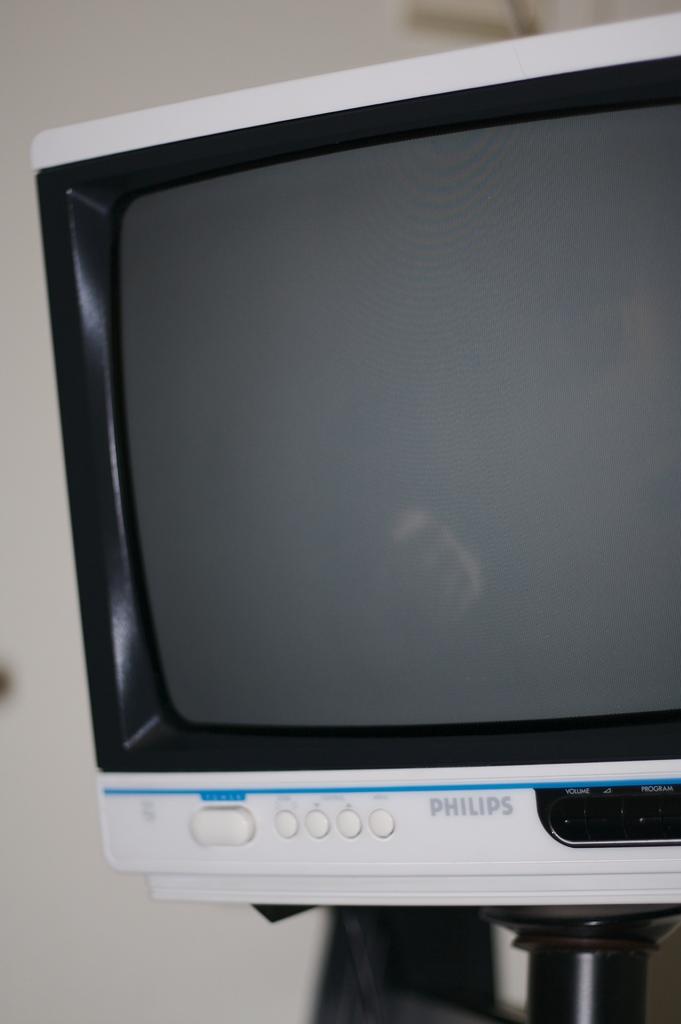What brand is this tv?
Provide a succinct answer. Philips. What do the black buttons control?
Give a very brief answer. Volume. 